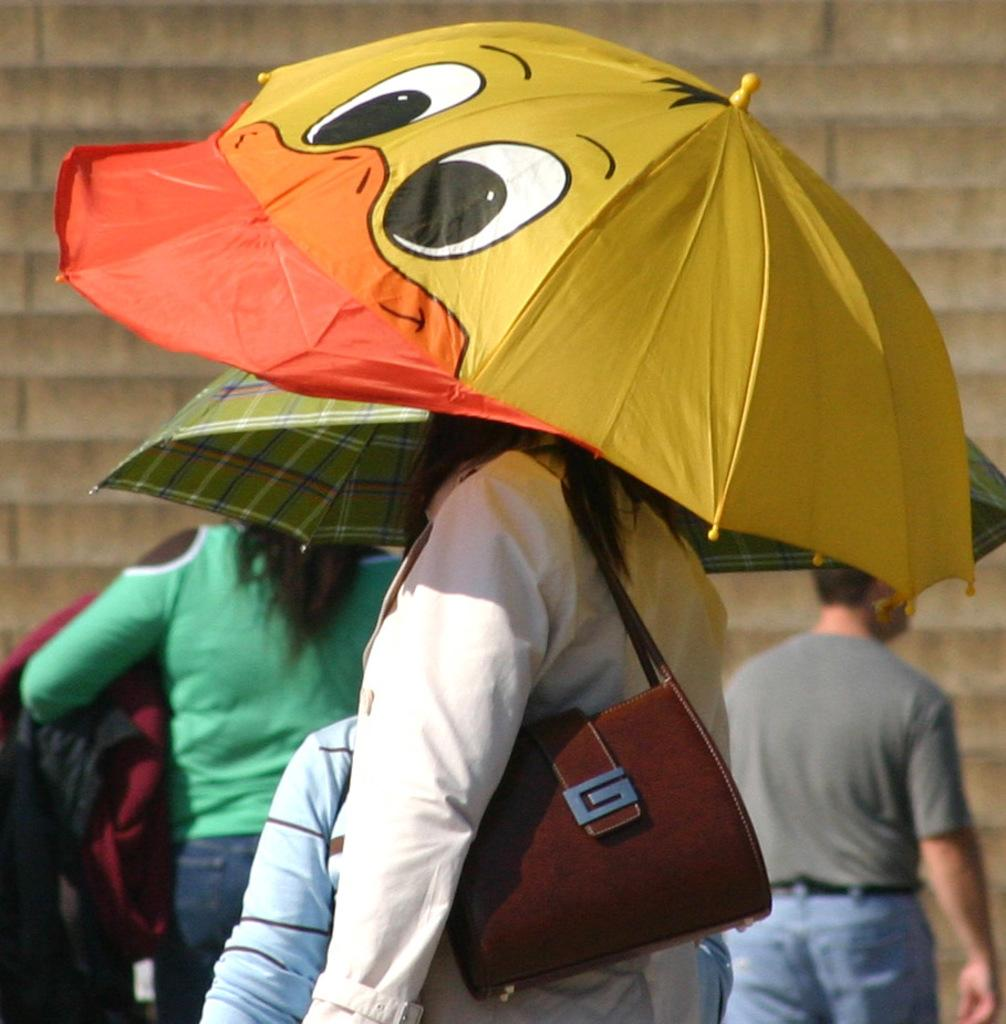What is the woman in the image holding? The woman is holding an umbrella and a handbag in the image. What is the other woman in the image doing? The other woman is standing in the image. What is the man in the image doing? The man is walking in the image. What type of stew is being served in the image? There is no stew present in the image; it features a woman with an umbrella, a man walking, and another woman standing. How is the glue being used in the image? There is no glue present in the image. 